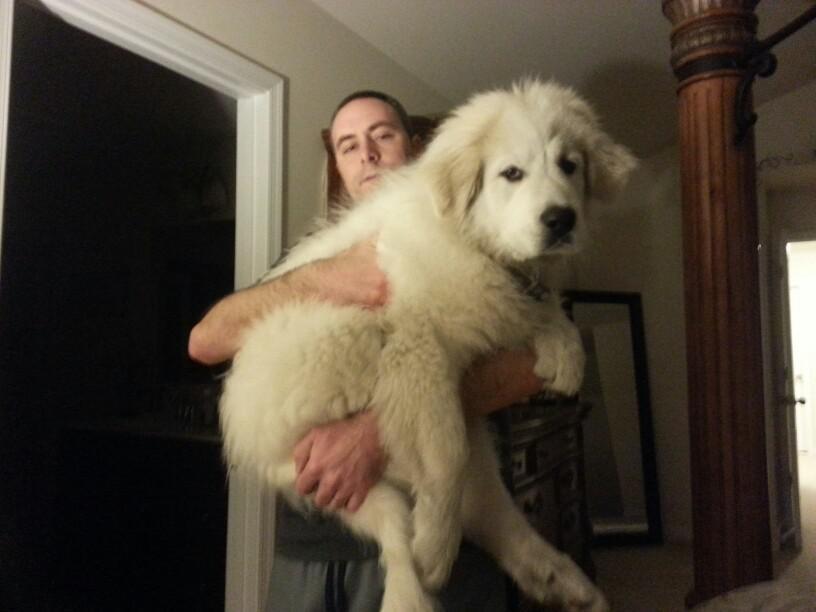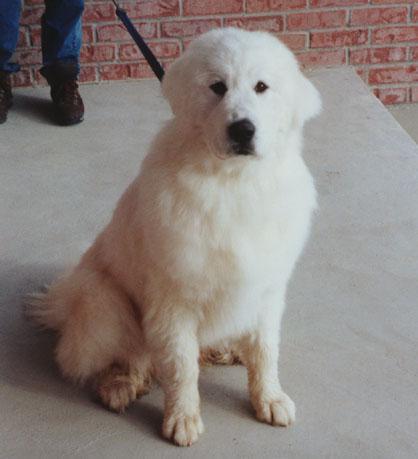The first image is the image on the left, the second image is the image on the right. For the images displayed, is the sentence "A person is holding a dog in one of the images." factually correct? Answer yes or no. Yes. The first image is the image on the left, the second image is the image on the right. Considering the images on both sides, is "In one image a large white dog is being held by a man, while the second image shows a white dog sitting near a person." valid? Answer yes or no. Yes. 